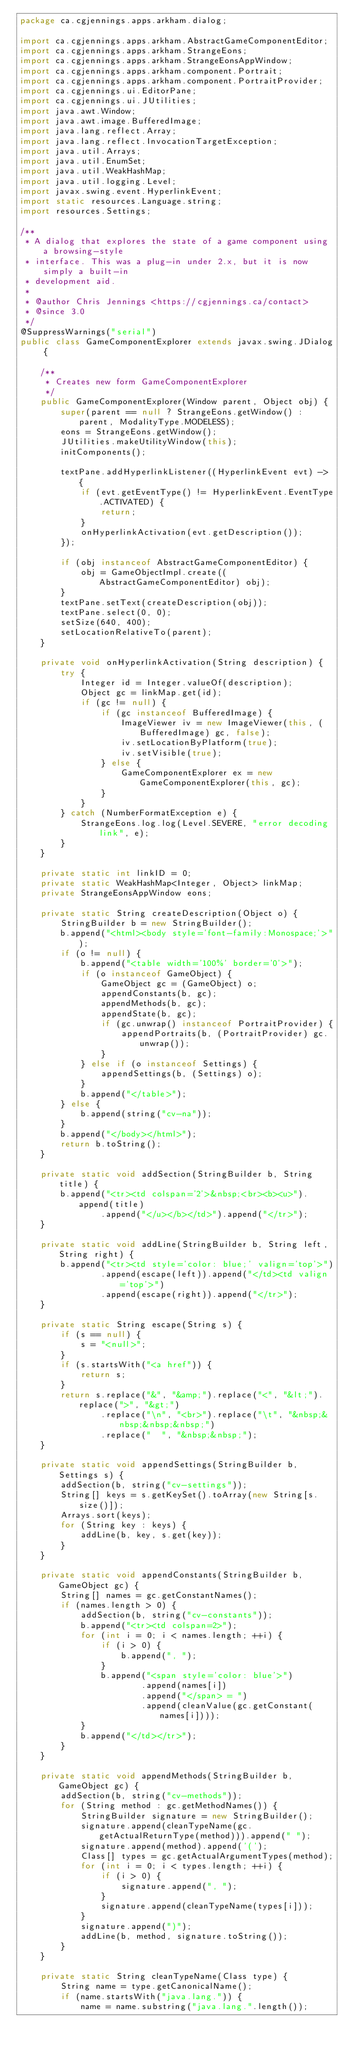Convert code to text. <code><loc_0><loc_0><loc_500><loc_500><_Java_>package ca.cgjennings.apps.arkham.dialog;

import ca.cgjennings.apps.arkham.AbstractGameComponentEditor;
import ca.cgjennings.apps.arkham.StrangeEons;
import ca.cgjennings.apps.arkham.StrangeEonsAppWindow;
import ca.cgjennings.apps.arkham.component.Portrait;
import ca.cgjennings.apps.arkham.component.PortraitProvider;
import ca.cgjennings.ui.EditorPane;
import ca.cgjennings.ui.JUtilities;
import java.awt.Window;
import java.awt.image.BufferedImage;
import java.lang.reflect.Array;
import java.lang.reflect.InvocationTargetException;
import java.util.Arrays;
import java.util.EnumSet;
import java.util.WeakHashMap;
import java.util.logging.Level;
import javax.swing.event.HyperlinkEvent;
import static resources.Language.string;
import resources.Settings;

/**
 * A dialog that explores the state of a game component using a browsing-style
 * interface. This was a plug-in under 2.x, but it is now simply a built-in
 * development aid.
 *
 * @author Chris Jennings <https://cgjennings.ca/contact>
 * @since 3.0
 */
@SuppressWarnings("serial")
public class GameComponentExplorer extends javax.swing.JDialog {

    /**
     * Creates new form GameComponentExplorer
     */
    public GameComponentExplorer(Window parent, Object obj) {
        super(parent == null ? StrangeEons.getWindow() : parent, ModalityType.MODELESS);
        eons = StrangeEons.getWindow();
        JUtilities.makeUtilityWindow(this);
        initComponents();

        textPane.addHyperlinkListener((HyperlinkEvent evt) -> {
            if (evt.getEventType() != HyperlinkEvent.EventType.ACTIVATED) {
                return;
            }
            onHyperlinkActivation(evt.getDescription());
        });

        if (obj instanceof AbstractGameComponentEditor) {
            obj = GameObjectImpl.create((AbstractGameComponentEditor) obj);
        }
        textPane.setText(createDescription(obj));
        textPane.select(0, 0);
        setSize(640, 400);
        setLocationRelativeTo(parent);
    }

    private void onHyperlinkActivation(String description) {
        try {
            Integer id = Integer.valueOf(description);
            Object gc = linkMap.get(id);
            if (gc != null) {
                if (gc instanceof BufferedImage) {
                    ImageViewer iv = new ImageViewer(this, (BufferedImage) gc, false);
                    iv.setLocationByPlatform(true);
                    iv.setVisible(true);
                } else {
                    GameComponentExplorer ex = new GameComponentExplorer(this, gc);
                }
            }
        } catch (NumberFormatException e) {
            StrangeEons.log.log(Level.SEVERE, "error decoding link", e);
        }
    }

    private static int linkID = 0;
    private static WeakHashMap<Integer, Object> linkMap;
    private StrangeEonsAppWindow eons;

    private static String createDescription(Object o) {
        StringBuilder b = new StringBuilder();
        b.append("<html><body style='font-family:Monospace;'>");
        if (o != null) {
            b.append("<table width='100%' border='0'>");
            if (o instanceof GameObject) {
                GameObject gc = (GameObject) o;
                appendConstants(b, gc);
                appendMethods(b, gc);
                appendState(b, gc);
                if (gc.unwrap() instanceof PortraitProvider) {
                    appendPortraits(b, (PortraitProvider) gc.unwrap());
                }
            } else if (o instanceof Settings) {
                appendSettings(b, (Settings) o);
            }
            b.append("</table>");
        } else {
            b.append(string("cv-na"));
        }
        b.append("</body></html>");
        return b.toString();
    }

    private static void addSection(StringBuilder b, String title) {
        b.append("<tr><td colspan='2'>&nbsp;<br><b><u>").append(title)
                .append("</u></b></td>").append("</tr>");
    }

    private static void addLine(StringBuilder b, String left, String right) {
        b.append("<tr><td style='color: blue;' valign='top'>")
                .append(escape(left)).append("</td><td valign='top'>")
                .append(escape(right)).append("</tr>");
    }

    private static String escape(String s) {
        if (s == null) {
            s = "<null>";
        }
        if (s.startsWith("<a href")) {
            return s;
        }
        return s.replace("&", "&amp;").replace("<", "&lt;").replace(">", "&gt;")
                .replace("\n", "<br>").replace("\t", "&nbsp;&nbsp;&nbsp;&nbsp;")
                .replace("  ", "&nbsp;&nbsp;");
    }

    private static void appendSettings(StringBuilder b, Settings s) {
        addSection(b, string("cv-settings"));
        String[] keys = s.getKeySet().toArray(new String[s.size()]);
        Arrays.sort(keys);
        for (String key : keys) {
            addLine(b, key, s.get(key));
        }
    }

    private static void appendConstants(StringBuilder b, GameObject gc) {
        String[] names = gc.getConstantNames();
        if (names.length > 0) {
            addSection(b, string("cv-constants"));
            b.append("<tr><td colspan=2>");
            for (int i = 0; i < names.length; ++i) {
                if (i > 0) {
                    b.append(", ");
                }
                b.append("<span style='color: blue'>")
                        .append(names[i])
                        .append("</span> = ")
                        .append(cleanValue(gc.getConstant(names[i])));
            }
            b.append("</td></tr>");
        }
    }

    private static void appendMethods(StringBuilder b, GameObject gc) {
        addSection(b, string("cv-methods"));
        for (String method : gc.getMethodNames()) {
            StringBuilder signature = new StringBuilder();
            signature.append(cleanTypeName(gc.getActualReturnType(method))).append(" ");
            signature.append(method).append('(');
            Class[] types = gc.getActualArgumentTypes(method);
            for (int i = 0; i < types.length; ++i) {
                if (i > 0) {
                    signature.append(", ");
                }
                signature.append(cleanTypeName(types[i]));
            }
            signature.append(")");
            addLine(b, method, signature.toString());
        }
    }

    private static String cleanTypeName(Class type) {
        String name = type.getCanonicalName();
        if (name.startsWith("java.lang.")) {
            name = name.substring("java.lang.".length());</code> 